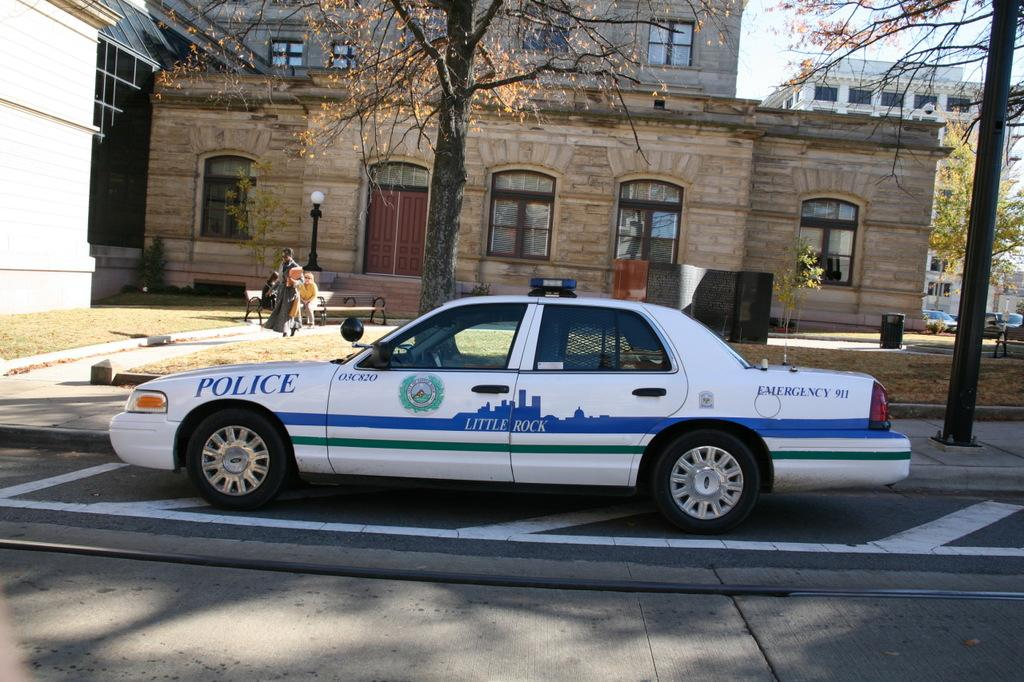What is the main subject in the foreground of the image? There is a car in the foreground of the image. What can be seen in the background of the image? Trees and buildings are visible behind the car in the image. Are there any people present in the image? Yes, there are people visible in the image. What type of eggs can be seen in the image? There are no eggs present in the image. Is there any oil visible in the image? There is no oil visible in the image. 